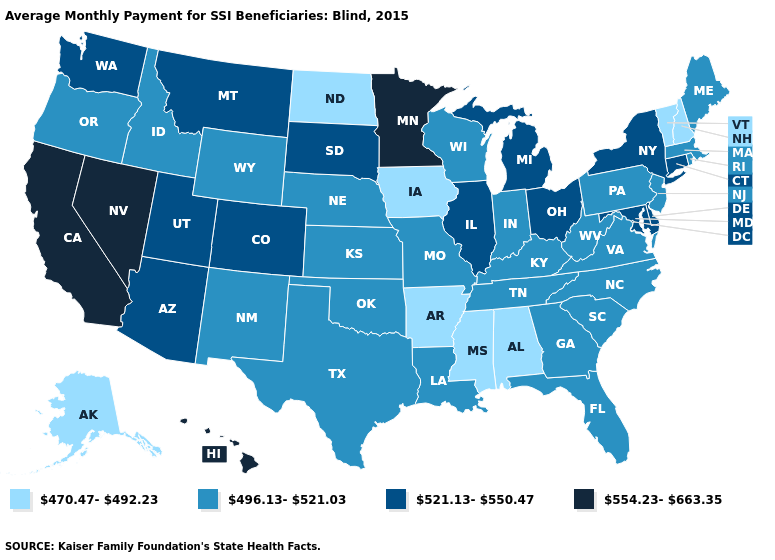Among the states that border Pennsylvania , does New Jersey have the lowest value?
Be succinct. Yes. What is the highest value in states that border Utah?
Answer briefly. 554.23-663.35. Among the states that border New Hampshire , which have the highest value?
Answer briefly. Maine, Massachusetts. Among the states that border West Virginia , which have the lowest value?
Give a very brief answer. Kentucky, Pennsylvania, Virginia. What is the highest value in the MidWest ?
Write a very short answer. 554.23-663.35. Does Delaware have the same value as Tennessee?
Quick response, please. No. Does Alaska have the same value as South Dakota?
Write a very short answer. No. Name the states that have a value in the range 554.23-663.35?
Write a very short answer. California, Hawaii, Minnesota, Nevada. Is the legend a continuous bar?
Short answer required. No. What is the value of New York?
Be succinct. 521.13-550.47. Name the states that have a value in the range 521.13-550.47?
Keep it brief. Arizona, Colorado, Connecticut, Delaware, Illinois, Maryland, Michigan, Montana, New York, Ohio, South Dakota, Utah, Washington. Among the states that border Virginia , does West Virginia have the lowest value?
Short answer required. Yes. Name the states that have a value in the range 521.13-550.47?
Give a very brief answer. Arizona, Colorado, Connecticut, Delaware, Illinois, Maryland, Michigan, Montana, New York, Ohio, South Dakota, Utah, Washington. Does Vermont have the lowest value in the USA?
Be succinct. Yes. Does Ohio have the lowest value in the MidWest?
Quick response, please. No. 